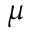Convert formula to latex. <formula><loc_0><loc_0><loc_500><loc_500>\mu</formula> 